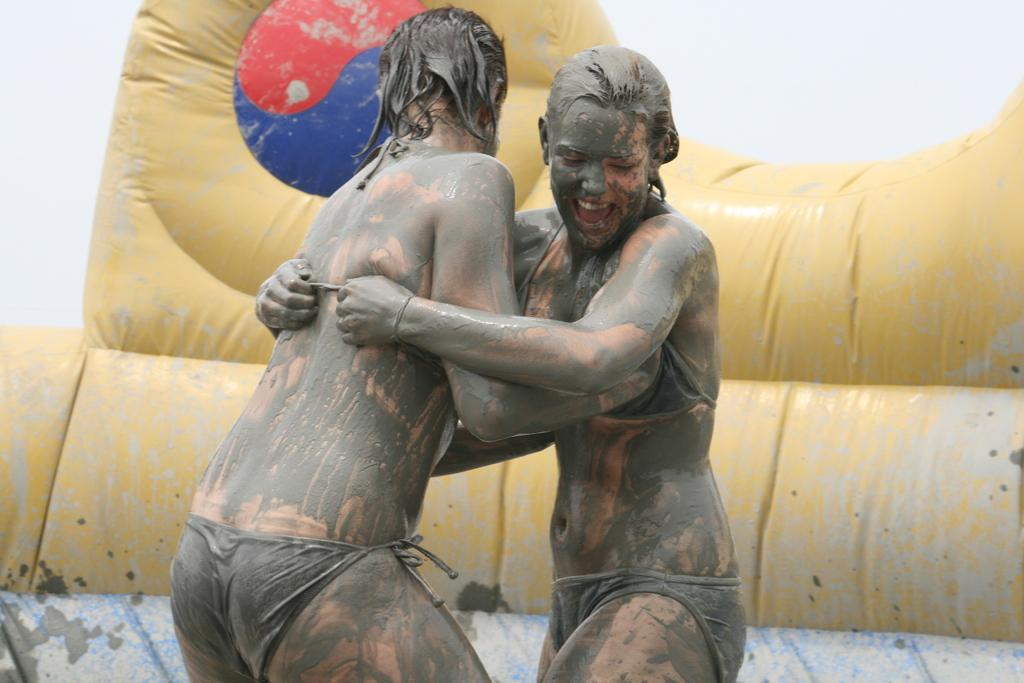How many people are in the image? There are two persons standing in the image. What is the condition of their bodies? The persons have mud on their bodies. What can be seen in the background of the image? There is an inflatable object in the background of the image. What color is the inflatable object? The inflatable object is yellow in color. How many parcels are being delivered to the persons in the image? There is no mention of parcels or delivery in the image. What type of books can be seen in the hands of the persons? There are no books present in the image. 